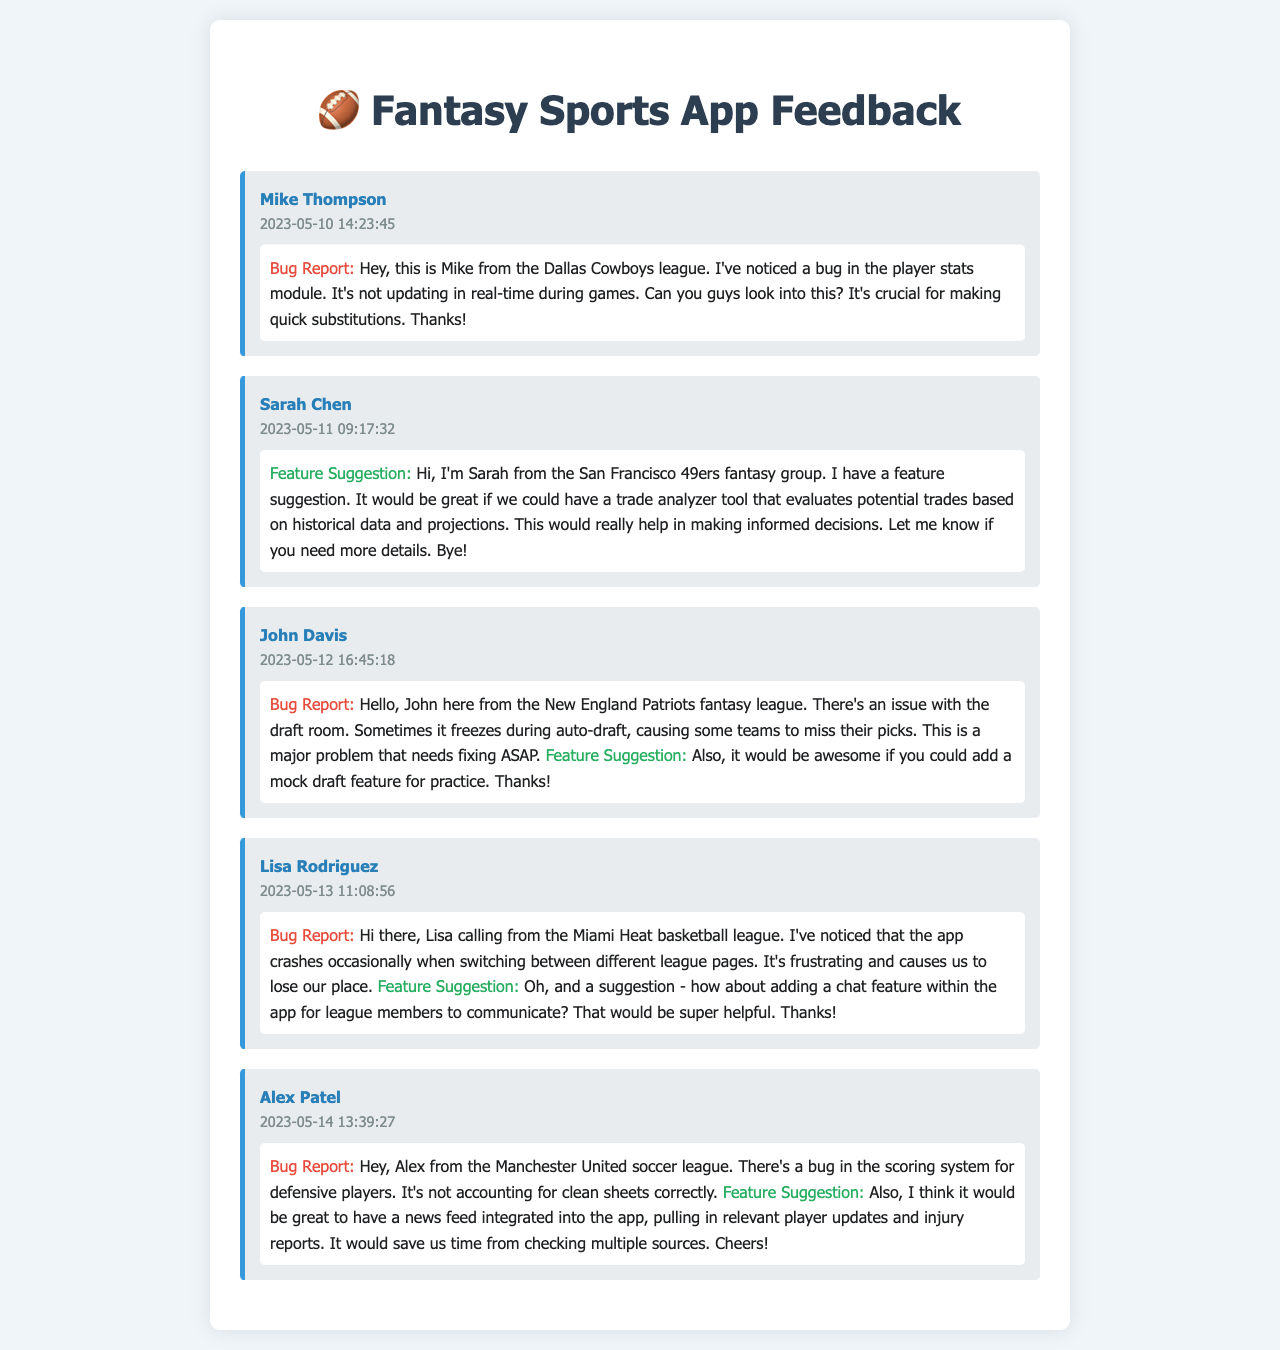What is the most reported bug? The most reported bug mentioned is the issue with the player stats module not updating in real-time during games, as highlighted by Mike Thompson.
Answer: Player stats module Who suggested a trade analyzer tool? Sarah Chen suggested the feature of a trade analyzer tool that evaluates potential trades.
Answer: Sarah Chen When did John Davis leave his voicemail? John Davis left his voicemail on May 12, 2023, at 16:45:18.
Answer: 2023-05-12 16:45:18 Which caller mentioned app crashes? Lisa Rodriguez mentioned experiencing app crashes when switching between different league pages.
Answer: Lisa Rodriguez What is the unique suggestion made by Alex Patel? Alex Patel suggested having a news feed integrated into the app for player updates and injury reports.
Answer: News feed How many callers reported bugs? A total of 4 callers reported bugs in their voicemails.
Answer: 4 Which league did Mike Thompson belong to? Mike Thompson belonged to the Dallas Cowboys league.
Answer: Dallas Cowboys What feature did Lisa suggest for the app? Lisa suggested adding a chat feature within the app for league members to communicate.
Answer: Chat feature What issue did John Davis report? John Davis reported that the draft room sometimes freezes during auto-draft.
Answer: Draft room freezing 